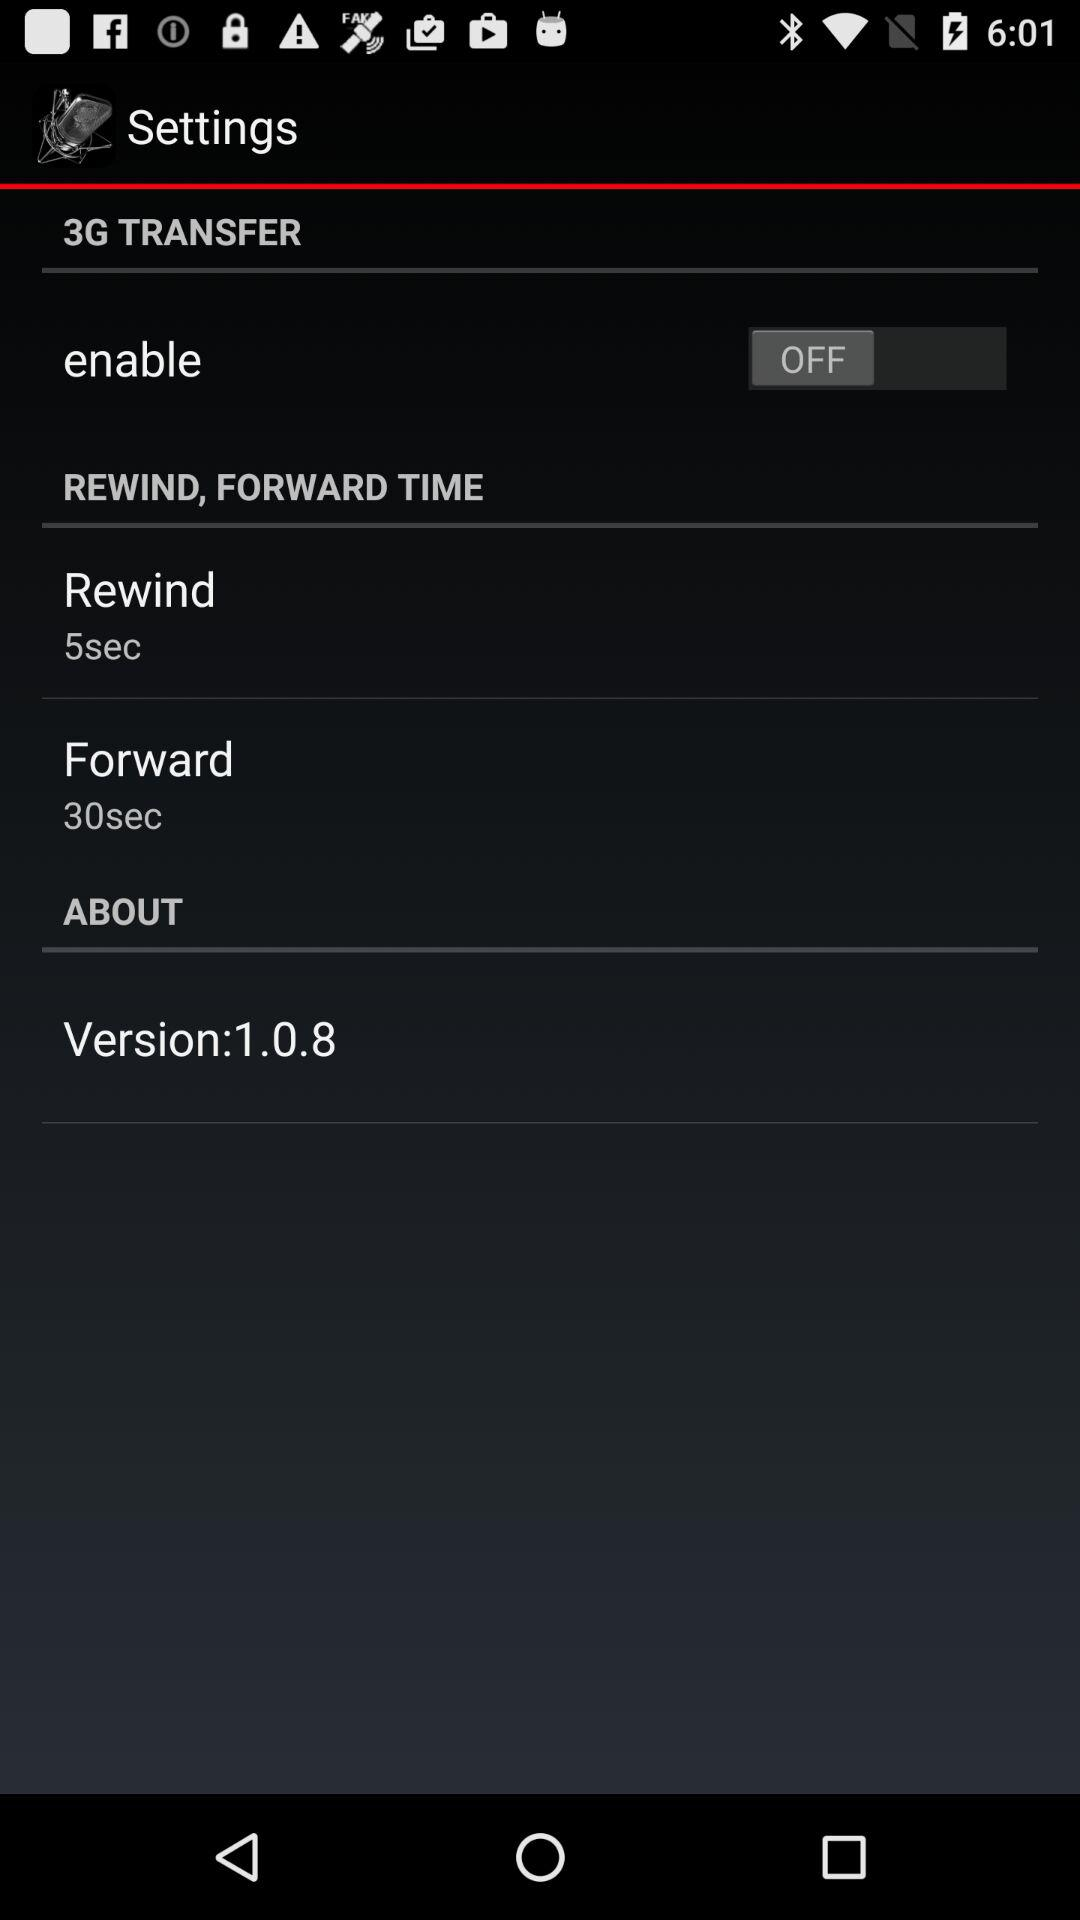What is the time of rewind? The time is 5 seconds. 